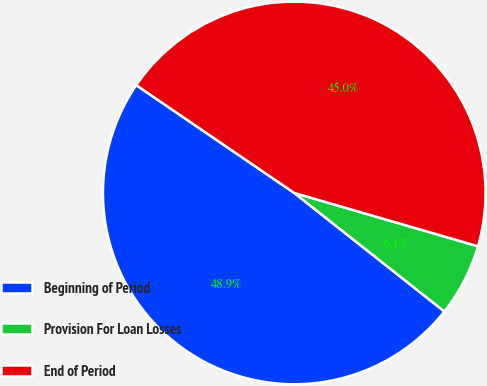<chart> <loc_0><loc_0><loc_500><loc_500><pie_chart><fcel>Beginning of Period<fcel>Provision For Loan Losses<fcel>End of Period<nl><fcel>48.89%<fcel>6.14%<fcel>44.97%<nl></chart> 